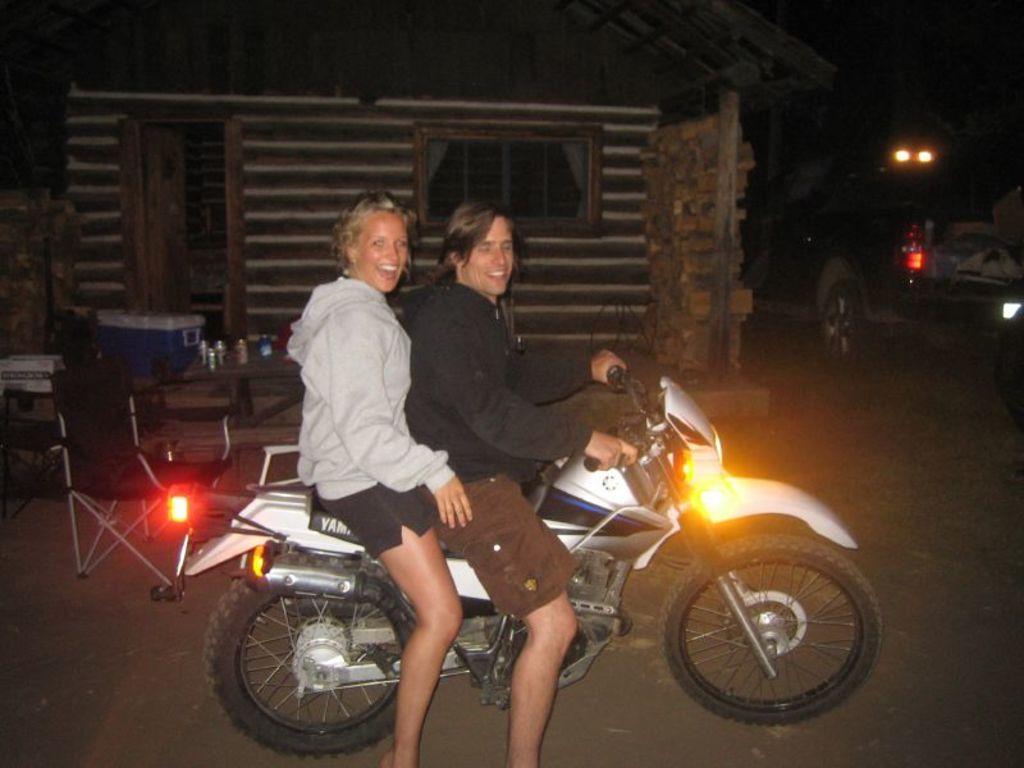In one or two sentences, can you explain what this image depicts? The two persons are sitting on a bike. They are smiling. The front side of the person is holding a handle. There is a table on the left side. There is a glass,tins and box on a table. We can see in the background house and vehicle. 